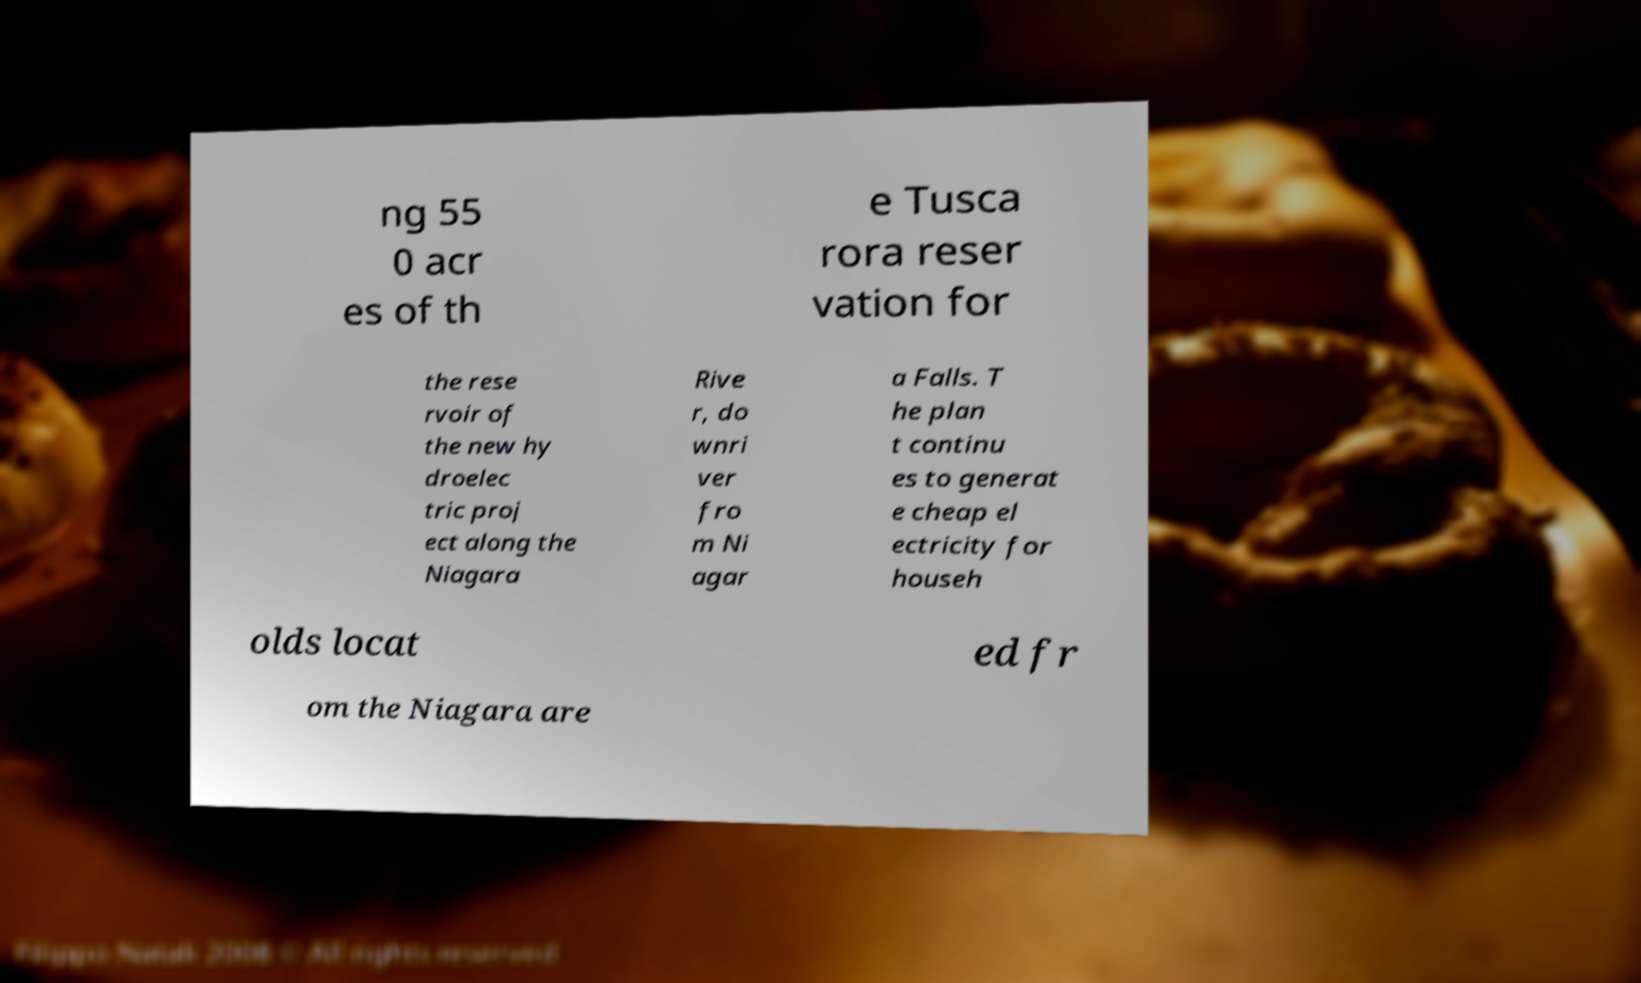Please read and relay the text visible in this image. What does it say? ng 55 0 acr es of th e Tusca rora reser vation for the rese rvoir of the new hy droelec tric proj ect along the Niagara Rive r, do wnri ver fro m Ni agar a Falls. T he plan t continu es to generat e cheap el ectricity for househ olds locat ed fr om the Niagara are 